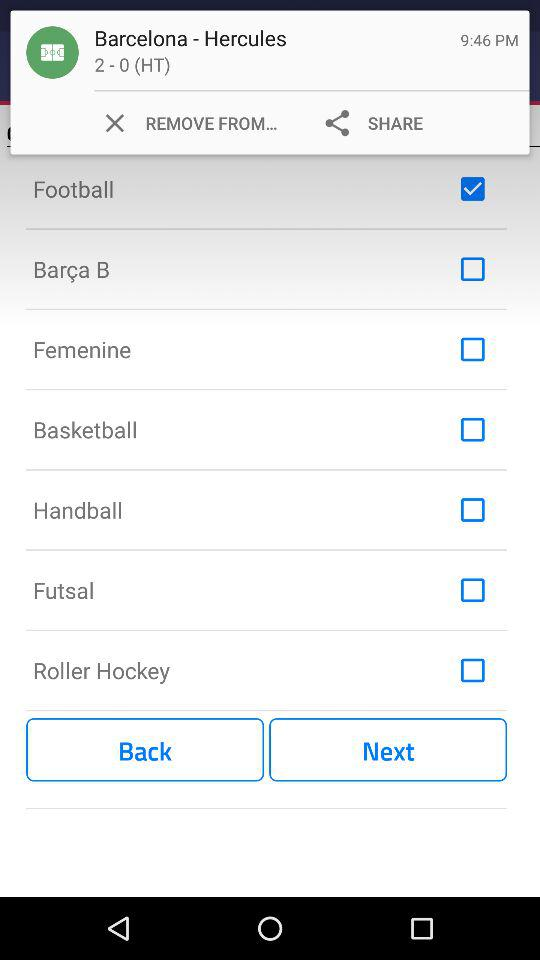What is the status of handball? The status is "off". 